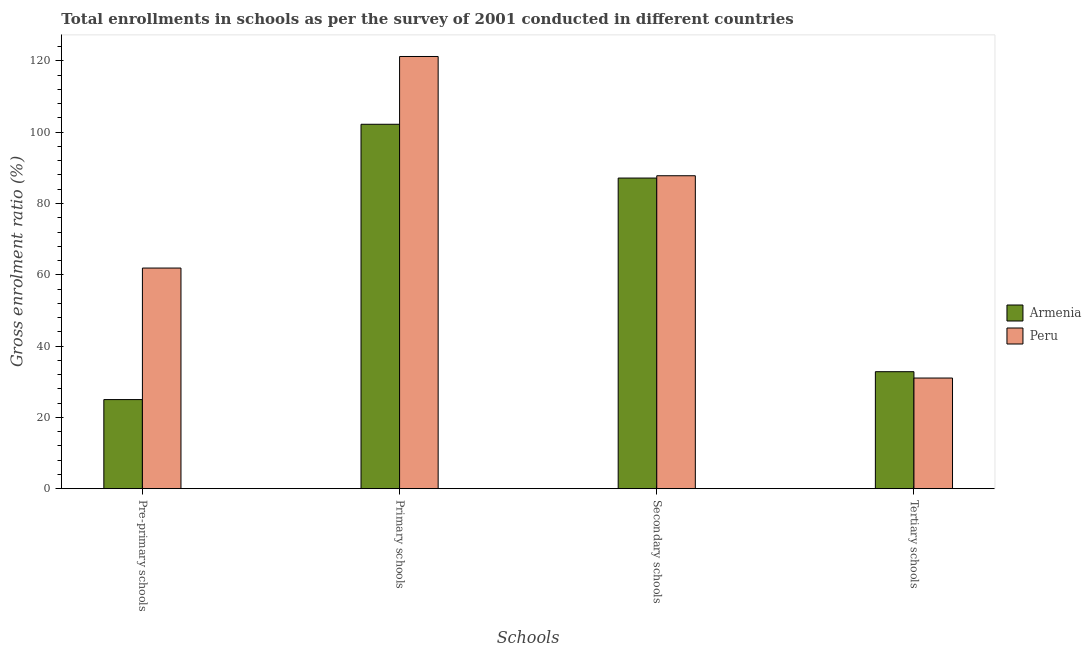Are the number of bars per tick equal to the number of legend labels?
Give a very brief answer. Yes. How many bars are there on the 1st tick from the right?
Provide a short and direct response. 2. What is the label of the 4th group of bars from the left?
Provide a succinct answer. Tertiary schools. What is the gross enrolment ratio in pre-primary schools in Peru?
Offer a very short reply. 61.89. Across all countries, what is the maximum gross enrolment ratio in secondary schools?
Keep it short and to the point. 87.79. Across all countries, what is the minimum gross enrolment ratio in pre-primary schools?
Offer a terse response. 24.99. In which country was the gross enrolment ratio in primary schools minimum?
Your answer should be compact. Armenia. What is the total gross enrolment ratio in secondary schools in the graph?
Provide a short and direct response. 174.92. What is the difference between the gross enrolment ratio in primary schools in Armenia and that in Peru?
Your response must be concise. -19.02. What is the difference between the gross enrolment ratio in primary schools in Peru and the gross enrolment ratio in pre-primary schools in Armenia?
Your answer should be compact. 96.25. What is the average gross enrolment ratio in primary schools per country?
Make the answer very short. 111.73. What is the difference between the gross enrolment ratio in secondary schools and gross enrolment ratio in pre-primary schools in Armenia?
Ensure brevity in your answer.  62.14. In how many countries, is the gross enrolment ratio in secondary schools greater than 60 %?
Provide a succinct answer. 2. What is the ratio of the gross enrolment ratio in tertiary schools in Armenia to that in Peru?
Keep it short and to the point. 1.06. Is the difference between the gross enrolment ratio in pre-primary schools in Peru and Armenia greater than the difference between the gross enrolment ratio in secondary schools in Peru and Armenia?
Your answer should be compact. Yes. What is the difference between the highest and the second highest gross enrolment ratio in primary schools?
Your answer should be compact. 19.02. What is the difference between the highest and the lowest gross enrolment ratio in secondary schools?
Offer a very short reply. 0.65. In how many countries, is the gross enrolment ratio in secondary schools greater than the average gross enrolment ratio in secondary schools taken over all countries?
Keep it short and to the point. 1. Is the sum of the gross enrolment ratio in secondary schools in Armenia and Peru greater than the maximum gross enrolment ratio in tertiary schools across all countries?
Offer a terse response. Yes. What does the 1st bar from the left in Pre-primary schools represents?
Keep it short and to the point. Armenia. What does the 2nd bar from the right in Pre-primary schools represents?
Offer a terse response. Armenia. How many bars are there?
Offer a terse response. 8. Are all the bars in the graph horizontal?
Ensure brevity in your answer.  No. How many countries are there in the graph?
Give a very brief answer. 2. What is the difference between two consecutive major ticks on the Y-axis?
Give a very brief answer. 20. Are the values on the major ticks of Y-axis written in scientific E-notation?
Provide a short and direct response. No. Does the graph contain any zero values?
Your response must be concise. No. How many legend labels are there?
Make the answer very short. 2. What is the title of the graph?
Provide a short and direct response. Total enrollments in schools as per the survey of 2001 conducted in different countries. Does "Bermuda" appear as one of the legend labels in the graph?
Ensure brevity in your answer.  No. What is the label or title of the X-axis?
Provide a succinct answer. Schools. What is the Gross enrolment ratio (%) in Armenia in Pre-primary schools?
Your answer should be compact. 24.99. What is the Gross enrolment ratio (%) of Peru in Pre-primary schools?
Give a very brief answer. 61.89. What is the Gross enrolment ratio (%) in Armenia in Primary schools?
Provide a succinct answer. 102.22. What is the Gross enrolment ratio (%) in Peru in Primary schools?
Offer a terse response. 121.24. What is the Gross enrolment ratio (%) in Armenia in Secondary schools?
Your answer should be very brief. 87.14. What is the Gross enrolment ratio (%) in Peru in Secondary schools?
Ensure brevity in your answer.  87.79. What is the Gross enrolment ratio (%) in Armenia in Tertiary schools?
Your answer should be compact. 32.81. What is the Gross enrolment ratio (%) of Peru in Tertiary schools?
Provide a short and direct response. 31.04. Across all Schools, what is the maximum Gross enrolment ratio (%) in Armenia?
Keep it short and to the point. 102.22. Across all Schools, what is the maximum Gross enrolment ratio (%) in Peru?
Ensure brevity in your answer.  121.24. Across all Schools, what is the minimum Gross enrolment ratio (%) in Armenia?
Your answer should be compact. 24.99. Across all Schools, what is the minimum Gross enrolment ratio (%) of Peru?
Provide a short and direct response. 31.04. What is the total Gross enrolment ratio (%) of Armenia in the graph?
Offer a very short reply. 247.17. What is the total Gross enrolment ratio (%) in Peru in the graph?
Offer a terse response. 301.95. What is the difference between the Gross enrolment ratio (%) in Armenia in Pre-primary schools and that in Primary schools?
Provide a succinct answer. -77.23. What is the difference between the Gross enrolment ratio (%) of Peru in Pre-primary schools and that in Primary schools?
Your answer should be very brief. -59.35. What is the difference between the Gross enrolment ratio (%) of Armenia in Pre-primary schools and that in Secondary schools?
Offer a terse response. -62.14. What is the difference between the Gross enrolment ratio (%) of Peru in Pre-primary schools and that in Secondary schools?
Offer a very short reply. -25.9. What is the difference between the Gross enrolment ratio (%) in Armenia in Pre-primary schools and that in Tertiary schools?
Offer a terse response. -7.82. What is the difference between the Gross enrolment ratio (%) in Peru in Pre-primary schools and that in Tertiary schools?
Your answer should be very brief. 30.85. What is the difference between the Gross enrolment ratio (%) in Armenia in Primary schools and that in Secondary schools?
Keep it short and to the point. 15.09. What is the difference between the Gross enrolment ratio (%) in Peru in Primary schools and that in Secondary schools?
Offer a very short reply. 33.45. What is the difference between the Gross enrolment ratio (%) of Armenia in Primary schools and that in Tertiary schools?
Provide a succinct answer. 69.41. What is the difference between the Gross enrolment ratio (%) of Peru in Primary schools and that in Tertiary schools?
Offer a terse response. 90.21. What is the difference between the Gross enrolment ratio (%) of Armenia in Secondary schools and that in Tertiary schools?
Ensure brevity in your answer.  54.32. What is the difference between the Gross enrolment ratio (%) of Peru in Secondary schools and that in Tertiary schools?
Your response must be concise. 56.75. What is the difference between the Gross enrolment ratio (%) of Armenia in Pre-primary schools and the Gross enrolment ratio (%) of Peru in Primary schools?
Ensure brevity in your answer.  -96.25. What is the difference between the Gross enrolment ratio (%) of Armenia in Pre-primary schools and the Gross enrolment ratio (%) of Peru in Secondary schools?
Your response must be concise. -62.79. What is the difference between the Gross enrolment ratio (%) of Armenia in Pre-primary schools and the Gross enrolment ratio (%) of Peru in Tertiary schools?
Provide a succinct answer. -6.04. What is the difference between the Gross enrolment ratio (%) of Armenia in Primary schools and the Gross enrolment ratio (%) of Peru in Secondary schools?
Your answer should be very brief. 14.44. What is the difference between the Gross enrolment ratio (%) in Armenia in Primary schools and the Gross enrolment ratio (%) in Peru in Tertiary schools?
Your answer should be compact. 71.19. What is the difference between the Gross enrolment ratio (%) in Armenia in Secondary schools and the Gross enrolment ratio (%) in Peru in Tertiary schools?
Your response must be concise. 56.1. What is the average Gross enrolment ratio (%) in Armenia per Schools?
Provide a succinct answer. 61.79. What is the average Gross enrolment ratio (%) in Peru per Schools?
Offer a terse response. 75.49. What is the difference between the Gross enrolment ratio (%) in Armenia and Gross enrolment ratio (%) in Peru in Pre-primary schools?
Provide a short and direct response. -36.9. What is the difference between the Gross enrolment ratio (%) in Armenia and Gross enrolment ratio (%) in Peru in Primary schools?
Your response must be concise. -19.02. What is the difference between the Gross enrolment ratio (%) of Armenia and Gross enrolment ratio (%) of Peru in Secondary schools?
Your answer should be very brief. -0.65. What is the difference between the Gross enrolment ratio (%) of Armenia and Gross enrolment ratio (%) of Peru in Tertiary schools?
Provide a short and direct response. 1.78. What is the ratio of the Gross enrolment ratio (%) of Armenia in Pre-primary schools to that in Primary schools?
Provide a succinct answer. 0.24. What is the ratio of the Gross enrolment ratio (%) in Peru in Pre-primary schools to that in Primary schools?
Keep it short and to the point. 0.51. What is the ratio of the Gross enrolment ratio (%) in Armenia in Pre-primary schools to that in Secondary schools?
Ensure brevity in your answer.  0.29. What is the ratio of the Gross enrolment ratio (%) of Peru in Pre-primary schools to that in Secondary schools?
Your answer should be compact. 0.7. What is the ratio of the Gross enrolment ratio (%) in Armenia in Pre-primary schools to that in Tertiary schools?
Give a very brief answer. 0.76. What is the ratio of the Gross enrolment ratio (%) of Peru in Pre-primary schools to that in Tertiary schools?
Your answer should be very brief. 1.99. What is the ratio of the Gross enrolment ratio (%) in Armenia in Primary schools to that in Secondary schools?
Your response must be concise. 1.17. What is the ratio of the Gross enrolment ratio (%) of Peru in Primary schools to that in Secondary schools?
Offer a very short reply. 1.38. What is the ratio of the Gross enrolment ratio (%) in Armenia in Primary schools to that in Tertiary schools?
Offer a very short reply. 3.12. What is the ratio of the Gross enrolment ratio (%) of Peru in Primary schools to that in Tertiary schools?
Make the answer very short. 3.91. What is the ratio of the Gross enrolment ratio (%) in Armenia in Secondary schools to that in Tertiary schools?
Your answer should be very brief. 2.66. What is the ratio of the Gross enrolment ratio (%) of Peru in Secondary schools to that in Tertiary schools?
Keep it short and to the point. 2.83. What is the difference between the highest and the second highest Gross enrolment ratio (%) in Armenia?
Give a very brief answer. 15.09. What is the difference between the highest and the second highest Gross enrolment ratio (%) of Peru?
Offer a terse response. 33.45. What is the difference between the highest and the lowest Gross enrolment ratio (%) in Armenia?
Make the answer very short. 77.23. What is the difference between the highest and the lowest Gross enrolment ratio (%) of Peru?
Provide a succinct answer. 90.21. 